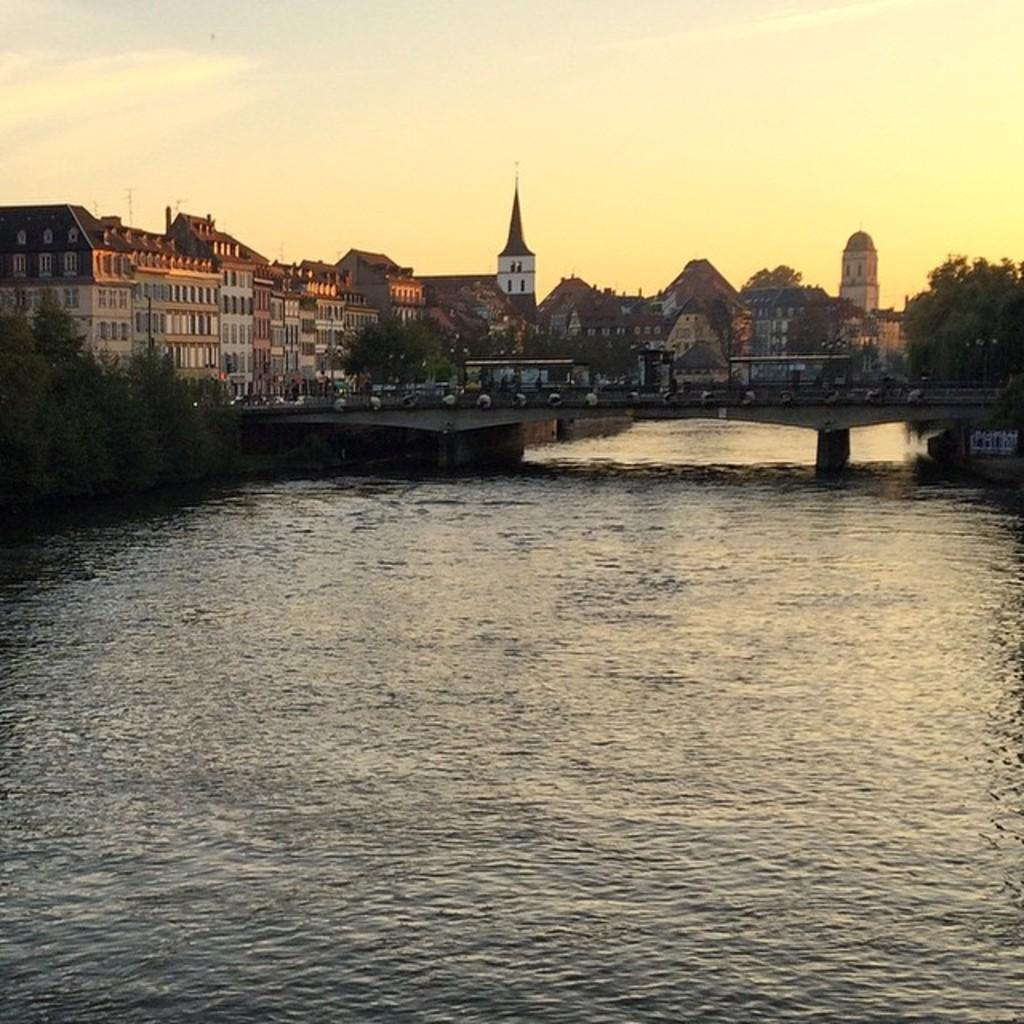What type of natural elements can be seen in the image? There are trees in the image. What type of man-made structures are present in the image? There are buildings in the image. What feature connects the two sides of the river in the image? There is a bridge across a river in the image. What is visible in the background of the image? The sky is visible in the background of the image. What type of dress is the river wearing in the image? The river is not wearing a dress, as it is a natural body of water and does not have clothing. Can you tell me how many glasses of eggnog are present in the image? There is no mention of eggnog or any beverages in the image; it features trees, buildings, a bridge, and the sky. 